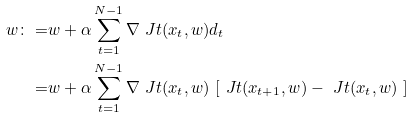Convert formula to latex. <formula><loc_0><loc_0><loc_500><loc_500>w \colon = & w + \alpha \sum _ { t = 1 } ^ { N - 1 } \nabla \ J t ( x _ { t } , w ) d _ { t } \\ = & w + \alpha \sum _ { t = 1 } ^ { N - 1 } \nabla \ J t ( x _ { t } , w ) \ [ \ J t ( x _ { t + 1 } , w ) - \ J t ( x _ { t } , w ) \ ]</formula> 